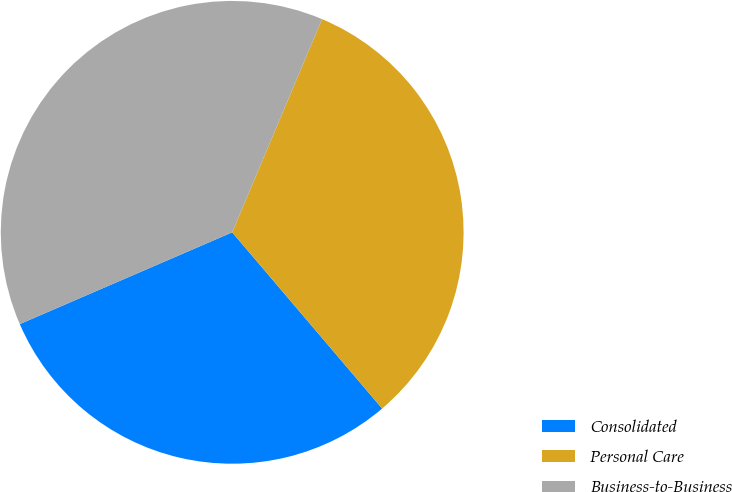<chart> <loc_0><loc_0><loc_500><loc_500><pie_chart><fcel>Consolidated<fcel>Personal Care<fcel>Business-to-Business<nl><fcel>29.73%<fcel>32.43%<fcel>37.84%<nl></chart> 